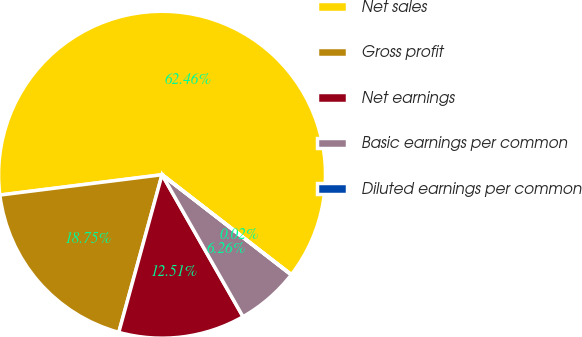<chart> <loc_0><loc_0><loc_500><loc_500><pie_chart><fcel>Net sales<fcel>Gross profit<fcel>Net earnings<fcel>Basic earnings per common<fcel>Diluted earnings per common<nl><fcel>62.45%<fcel>18.75%<fcel>12.51%<fcel>6.26%<fcel>0.02%<nl></chart> 